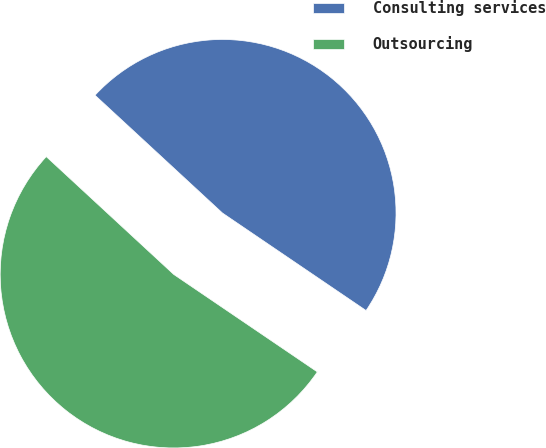Convert chart. <chart><loc_0><loc_0><loc_500><loc_500><pie_chart><fcel>Consulting services<fcel>Outsourcing<nl><fcel>47.62%<fcel>52.38%<nl></chart> 